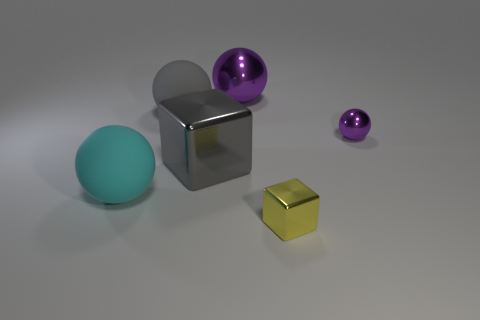There is a large metallic block; does it have the same color as the cube that is in front of the cyan rubber object?
Provide a succinct answer. No. Are there any spheres behind the big shiny block?
Offer a very short reply. Yes. Does the cyan object have the same material as the tiny ball?
Keep it short and to the point. No. What material is the cyan ball that is the same size as the gray shiny cube?
Keep it short and to the point. Rubber. How many objects are either large purple metallic objects to the left of the yellow metallic object or small brown cubes?
Provide a succinct answer. 1. Is the number of big purple objects that are left of the large cube the same as the number of small yellow cylinders?
Provide a succinct answer. Yes. Does the big metallic sphere have the same color as the small metal ball?
Your response must be concise. Yes. There is a metallic thing that is both behind the big gray shiny block and on the left side of the yellow metal block; what is its color?
Provide a succinct answer. Purple. What number of cubes are gray metal things or big rubber things?
Your response must be concise. 1. Are there fewer large gray objects that are in front of the yellow metal block than tiny blue rubber blocks?
Offer a terse response. No. 